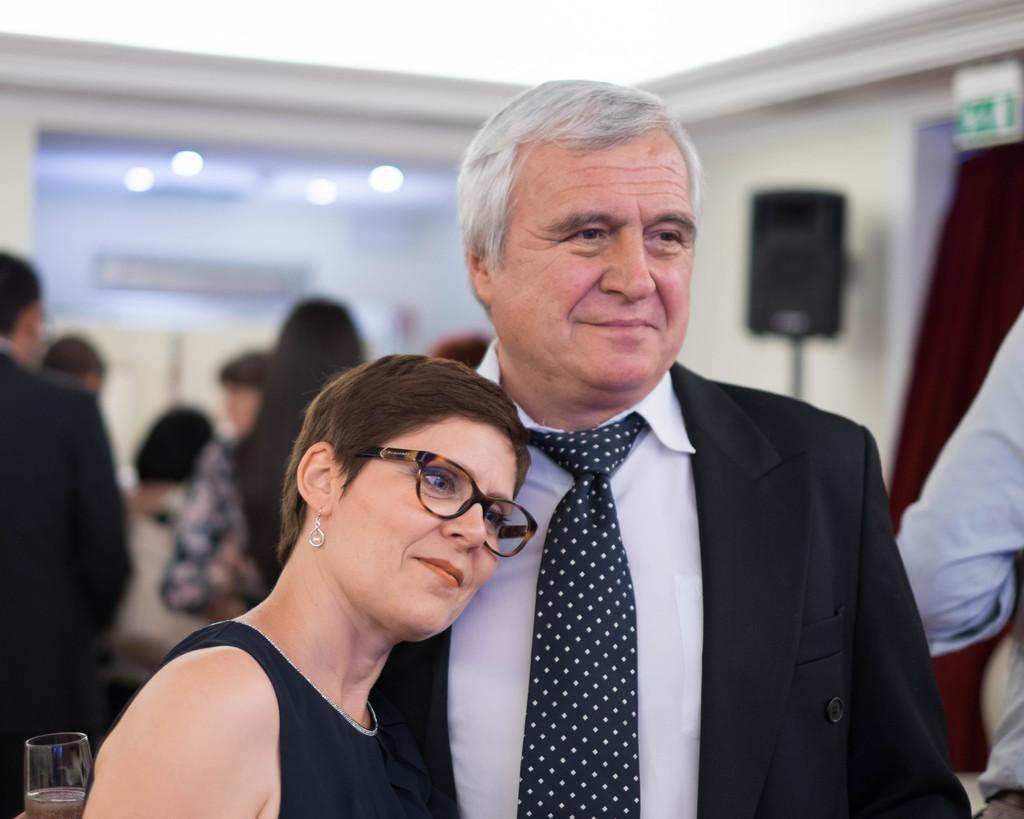Describe this image in one or two sentences. In this image I can see two people with white and black color dresses. To the left I can see the glass. In the background I can see few more people with different color dresses. I can see the maroon color curtain and the sound box. I can also see the lights and there is a blurred background. 